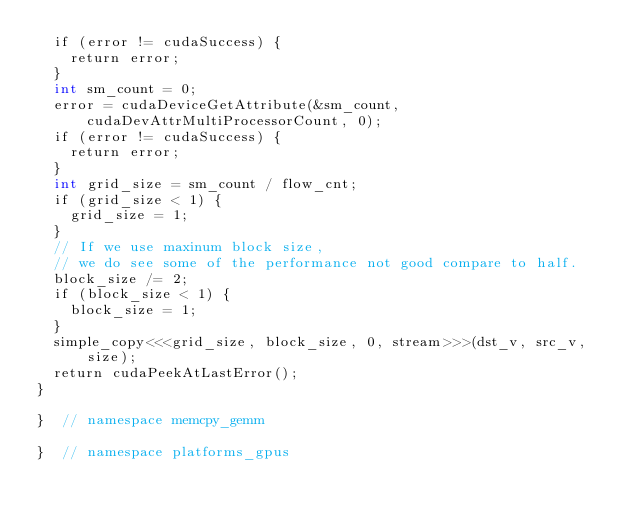<code> <loc_0><loc_0><loc_500><loc_500><_Cuda_>  if (error != cudaSuccess) {
    return error;
  }
  int sm_count = 0;
  error = cudaDeviceGetAttribute(&sm_count, cudaDevAttrMultiProcessorCount, 0);
  if (error != cudaSuccess) {
    return error;
  }
  int grid_size = sm_count / flow_cnt;
  if (grid_size < 1) {
    grid_size = 1;
  }
  // If we use maxinum block size,
  // we do see some of the performance not good compare to half.
  block_size /= 2;
  if (block_size < 1) {
    block_size = 1;
  }
  simple_copy<<<grid_size, block_size, 0, stream>>>(dst_v, src_v, size);
  return cudaPeekAtLastError();
}

}  // namespace memcpy_gemm

}  // namespace platforms_gpus
</code> 